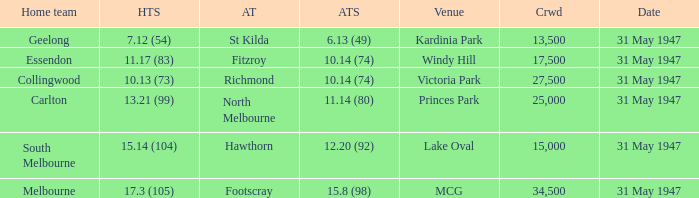What day is south melbourne at home? 31 May 1947. 